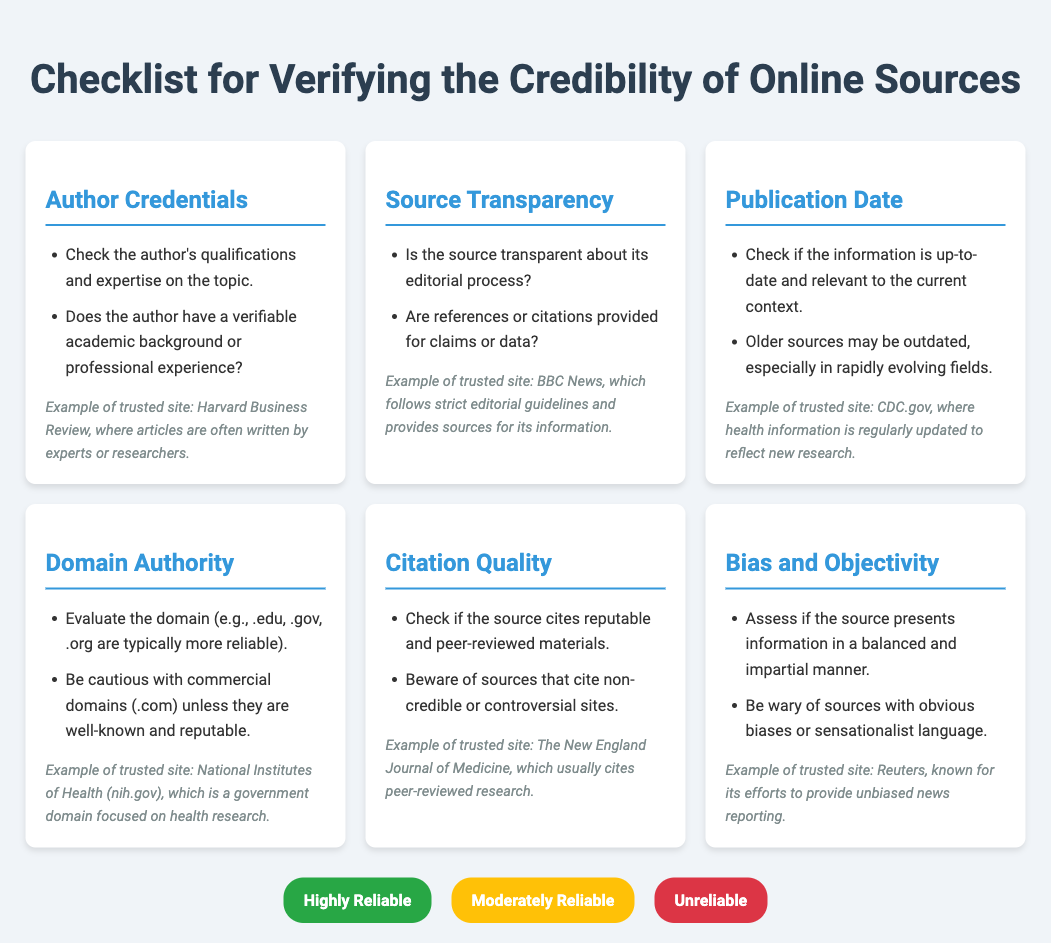What is the first item in the checklist? The first item is about evaluating the author's qualifications and expertise on the topic mentioned in the checklist.
Answer: Author Credentials What trusted site is associated with source transparency? The example given for trusted site related to source transparency is well-known for following strict editorial guidelines and providing sources for information.
Answer: BBC News Which domain types are mentioned as typically more reliable? The checklist indicates that domains such as .edu, .gov, and .org are typically seen as more reliable than commercial domains.
Answer: .edu, .gov, .org What is the reliability rating color for Highly Reliable? The document provides specific colors for reliability markers, where the color associated with Highly Reliable is vibrant and stands out among others.
Answer: Green Which site is highlighted for updating health information regularly? The checklist points out a trusted site where health information is frequently updated reflecting new research developments.
Answer: CDC.gov What does the checklist advise to beware of in citation quality? According to the document, it is important to be cautious with sources that cite non-credible or controversial sites, indicating a need for quality in citations.
Answer: Non-credible Which site is mentioned as known for unbiased news reporting? The document mentions a specific site recognized for their efforts to provide news in an unbiased manner, providing users with credible reporting.
Answer: Reuters How many items are there in the checklist? By counting the structured sections, the checklist has a specific number of key items addressing different criteria for verifying online sources.
Answer: Six 